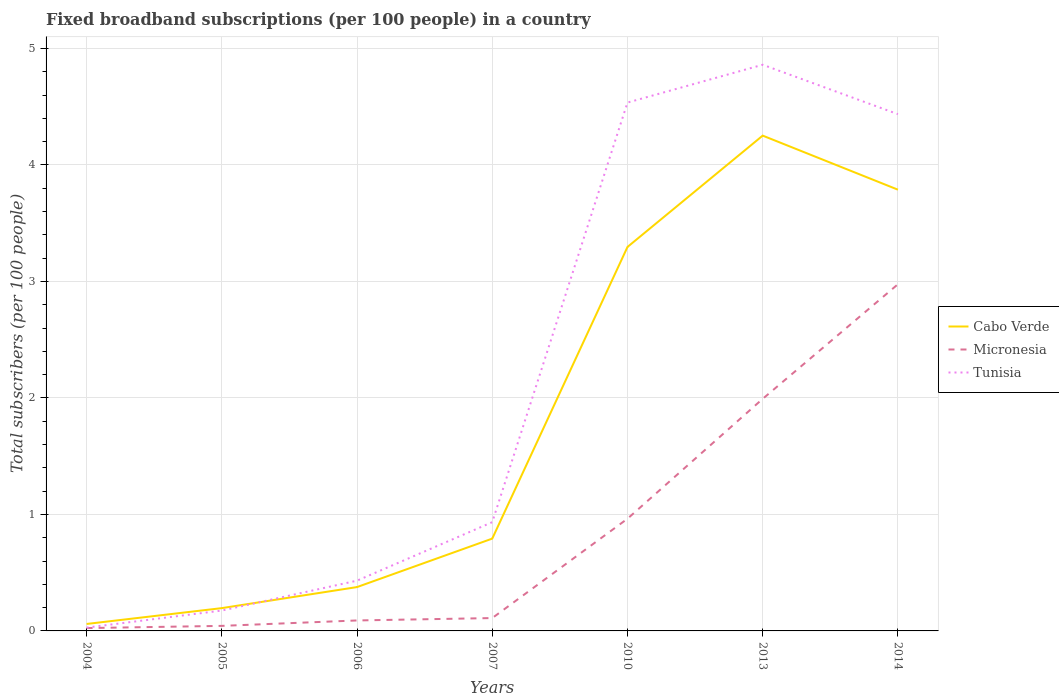How many different coloured lines are there?
Keep it short and to the point. 3. Across all years, what is the maximum number of broadband subscriptions in Tunisia?
Your response must be concise. 0.03. What is the total number of broadband subscriptions in Tunisia in the graph?
Provide a succinct answer. -4.69. What is the difference between the highest and the second highest number of broadband subscriptions in Tunisia?
Your answer should be very brief. 4.83. What is the difference between the highest and the lowest number of broadband subscriptions in Micronesia?
Your answer should be very brief. 3. Is the number of broadband subscriptions in Tunisia strictly greater than the number of broadband subscriptions in Micronesia over the years?
Keep it short and to the point. No. What is the difference between two consecutive major ticks on the Y-axis?
Offer a terse response. 1. How many legend labels are there?
Offer a very short reply. 3. How are the legend labels stacked?
Your answer should be compact. Vertical. What is the title of the graph?
Offer a very short reply. Fixed broadband subscriptions (per 100 people) in a country. Does "Palau" appear as one of the legend labels in the graph?
Make the answer very short. No. What is the label or title of the Y-axis?
Offer a very short reply. Total subscribers (per 100 people). What is the Total subscribers (per 100 people) of Cabo Verde in 2004?
Make the answer very short. 0.06. What is the Total subscribers (per 100 people) in Micronesia in 2004?
Provide a succinct answer. 0.02. What is the Total subscribers (per 100 people) in Tunisia in 2004?
Provide a succinct answer. 0.03. What is the Total subscribers (per 100 people) in Cabo Verde in 2005?
Offer a very short reply. 0.2. What is the Total subscribers (per 100 people) in Micronesia in 2005?
Your answer should be very brief. 0.04. What is the Total subscribers (per 100 people) of Tunisia in 2005?
Offer a very short reply. 0.17. What is the Total subscribers (per 100 people) in Cabo Verde in 2006?
Make the answer very short. 0.38. What is the Total subscribers (per 100 people) of Micronesia in 2006?
Your answer should be very brief. 0.09. What is the Total subscribers (per 100 people) in Tunisia in 2006?
Your answer should be compact. 0.43. What is the Total subscribers (per 100 people) of Cabo Verde in 2007?
Offer a very short reply. 0.79. What is the Total subscribers (per 100 people) in Micronesia in 2007?
Provide a succinct answer. 0.11. What is the Total subscribers (per 100 people) of Tunisia in 2007?
Ensure brevity in your answer.  0.93. What is the Total subscribers (per 100 people) of Cabo Verde in 2010?
Your answer should be compact. 3.3. What is the Total subscribers (per 100 people) of Micronesia in 2010?
Provide a short and direct response. 0.96. What is the Total subscribers (per 100 people) of Tunisia in 2010?
Your answer should be compact. 4.54. What is the Total subscribers (per 100 people) of Cabo Verde in 2013?
Offer a very short reply. 4.25. What is the Total subscribers (per 100 people) in Micronesia in 2013?
Offer a very short reply. 1.99. What is the Total subscribers (per 100 people) in Tunisia in 2013?
Your response must be concise. 4.86. What is the Total subscribers (per 100 people) of Cabo Verde in 2014?
Provide a short and direct response. 3.79. What is the Total subscribers (per 100 people) of Micronesia in 2014?
Offer a terse response. 2.98. What is the Total subscribers (per 100 people) of Tunisia in 2014?
Give a very brief answer. 4.44. Across all years, what is the maximum Total subscribers (per 100 people) in Cabo Verde?
Provide a short and direct response. 4.25. Across all years, what is the maximum Total subscribers (per 100 people) in Micronesia?
Provide a succinct answer. 2.98. Across all years, what is the maximum Total subscribers (per 100 people) in Tunisia?
Offer a very short reply. 4.86. Across all years, what is the minimum Total subscribers (per 100 people) of Cabo Verde?
Make the answer very short. 0.06. Across all years, what is the minimum Total subscribers (per 100 people) of Micronesia?
Your response must be concise. 0.02. Across all years, what is the minimum Total subscribers (per 100 people) of Tunisia?
Offer a terse response. 0.03. What is the total Total subscribers (per 100 people) of Cabo Verde in the graph?
Give a very brief answer. 12.76. What is the total Total subscribers (per 100 people) of Micronesia in the graph?
Your response must be concise. 6.2. What is the total Total subscribers (per 100 people) in Tunisia in the graph?
Your answer should be compact. 15.4. What is the difference between the Total subscribers (per 100 people) in Cabo Verde in 2004 and that in 2005?
Your response must be concise. -0.14. What is the difference between the Total subscribers (per 100 people) in Micronesia in 2004 and that in 2005?
Keep it short and to the point. -0.02. What is the difference between the Total subscribers (per 100 people) in Tunisia in 2004 and that in 2005?
Your response must be concise. -0.15. What is the difference between the Total subscribers (per 100 people) in Cabo Verde in 2004 and that in 2006?
Your response must be concise. -0.32. What is the difference between the Total subscribers (per 100 people) in Micronesia in 2004 and that in 2006?
Offer a terse response. -0.07. What is the difference between the Total subscribers (per 100 people) of Tunisia in 2004 and that in 2006?
Your answer should be very brief. -0.4. What is the difference between the Total subscribers (per 100 people) in Cabo Verde in 2004 and that in 2007?
Keep it short and to the point. -0.73. What is the difference between the Total subscribers (per 100 people) in Micronesia in 2004 and that in 2007?
Your answer should be very brief. -0.09. What is the difference between the Total subscribers (per 100 people) in Tunisia in 2004 and that in 2007?
Give a very brief answer. -0.91. What is the difference between the Total subscribers (per 100 people) of Cabo Verde in 2004 and that in 2010?
Your response must be concise. -3.24. What is the difference between the Total subscribers (per 100 people) in Micronesia in 2004 and that in 2010?
Your answer should be very brief. -0.94. What is the difference between the Total subscribers (per 100 people) in Tunisia in 2004 and that in 2010?
Ensure brevity in your answer.  -4.51. What is the difference between the Total subscribers (per 100 people) in Cabo Verde in 2004 and that in 2013?
Offer a terse response. -4.19. What is the difference between the Total subscribers (per 100 people) in Micronesia in 2004 and that in 2013?
Offer a very short reply. -1.97. What is the difference between the Total subscribers (per 100 people) in Tunisia in 2004 and that in 2013?
Give a very brief answer. -4.83. What is the difference between the Total subscribers (per 100 people) in Cabo Verde in 2004 and that in 2014?
Give a very brief answer. -3.73. What is the difference between the Total subscribers (per 100 people) of Micronesia in 2004 and that in 2014?
Provide a succinct answer. -2.95. What is the difference between the Total subscribers (per 100 people) of Tunisia in 2004 and that in 2014?
Offer a terse response. -4.41. What is the difference between the Total subscribers (per 100 people) of Cabo Verde in 2005 and that in 2006?
Keep it short and to the point. -0.18. What is the difference between the Total subscribers (per 100 people) in Micronesia in 2005 and that in 2006?
Offer a very short reply. -0.05. What is the difference between the Total subscribers (per 100 people) of Tunisia in 2005 and that in 2006?
Keep it short and to the point. -0.26. What is the difference between the Total subscribers (per 100 people) of Cabo Verde in 2005 and that in 2007?
Provide a short and direct response. -0.6. What is the difference between the Total subscribers (per 100 people) of Micronesia in 2005 and that in 2007?
Give a very brief answer. -0.07. What is the difference between the Total subscribers (per 100 people) in Tunisia in 2005 and that in 2007?
Your answer should be compact. -0.76. What is the difference between the Total subscribers (per 100 people) in Cabo Verde in 2005 and that in 2010?
Make the answer very short. -3.1. What is the difference between the Total subscribers (per 100 people) of Micronesia in 2005 and that in 2010?
Ensure brevity in your answer.  -0.92. What is the difference between the Total subscribers (per 100 people) in Tunisia in 2005 and that in 2010?
Keep it short and to the point. -4.36. What is the difference between the Total subscribers (per 100 people) of Cabo Verde in 2005 and that in 2013?
Offer a terse response. -4.06. What is the difference between the Total subscribers (per 100 people) in Micronesia in 2005 and that in 2013?
Your response must be concise. -1.95. What is the difference between the Total subscribers (per 100 people) in Tunisia in 2005 and that in 2013?
Provide a short and direct response. -4.69. What is the difference between the Total subscribers (per 100 people) in Cabo Verde in 2005 and that in 2014?
Your answer should be compact. -3.59. What is the difference between the Total subscribers (per 100 people) of Micronesia in 2005 and that in 2014?
Your answer should be very brief. -2.93. What is the difference between the Total subscribers (per 100 people) of Tunisia in 2005 and that in 2014?
Keep it short and to the point. -4.26. What is the difference between the Total subscribers (per 100 people) in Cabo Verde in 2006 and that in 2007?
Your answer should be very brief. -0.42. What is the difference between the Total subscribers (per 100 people) of Micronesia in 2006 and that in 2007?
Your answer should be compact. -0.02. What is the difference between the Total subscribers (per 100 people) in Tunisia in 2006 and that in 2007?
Provide a succinct answer. -0.5. What is the difference between the Total subscribers (per 100 people) of Cabo Verde in 2006 and that in 2010?
Offer a terse response. -2.92. What is the difference between the Total subscribers (per 100 people) in Micronesia in 2006 and that in 2010?
Provide a succinct answer. -0.87. What is the difference between the Total subscribers (per 100 people) in Tunisia in 2006 and that in 2010?
Make the answer very short. -4.1. What is the difference between the Total subscribers (per 100 people) in Cabo Verde in 2006 and that in 2013?
Keep it short and to the point. -3.88. What is the difference between the Total subscribers (per 100 people) in Micronesia in 2006 and that in 2013?
Provide a short and direct response. -1.9. What is the difference between the Total subscribers (per 100 people) in Tunisia in 2006 and that in 2013?
Offer a terse response. -4.43. What is the difference between the Total subscribers (per 100 people) in Cabo Verde in 2006 and that in 2014?
Ensure brevity in your answer.  -3.41. What is the difference between the Total subscribers (per 100 people) in Micronesia in 2006 and that in 2014?
Offer a very short reply. -2.89. What is the difference between the Total subscribers (per 100 people) of Tunisia in 2006 and that in 2014?
Offer a very short reply. -4. What is the difference between the Total subscribers (per 100 people) of Cabo Verde in 2007 and that in 2010?
Keep it short and to the point. -2.5. What is the difference between the Total subscribers (per 100 people) of Micronesia in 2007 and that in 2010?
Offer a terse response. -0.85. What is the difference between the Total subscribers (per 100 people) of Tunisia in 2007 and that in 2010?
Give a very brief answer. -3.6. What is the difference between the Total subscribers (per 100 people) of Cabo Verde in 2007 and that in 2013?
Your answer should be very brief. -3.46. What is the difference between the Total subscribers (per 100 people) of Micronesia in 2007 and that in 2013?
Provide a succinct answer. -1.88. What is the difference between the Total subscribers (per 100 people) in Tunisia in 2007 and that in 2013?
Keep it short and to the point. -3.93. What is the difference between the Total subscribers (per 100 people) in Cabo Verde in 2007 and that in 2014?
Keep it short and to the point. -3. What is the difference between the Total subscribers (per 100 people) in Micronesia in 2007 and that in 2014?
Make the answer very short. -2.87. What is the difference between the Total subscribers (per 100 people) in Tunisia in 2007 and that in 2014?
Provide a short and direct response. -3.5. What is the difference between the Total subscribers (per 100 people) of Cabo Verde in 2010 and that in 2013?
Your response must be concise. -0.96. What is the difference between the Total subscribers (per 100 people) of Micronesia in 2010 and that in 2013?
Offer a very short reply. -1.03. What is the difference between the Total subscribers (per 100 people) in Tunisia in 2010 and that in 2013?
Make the answer very short. -0.32. What is the difference between the Total subscribers (per 100 people) of Cabo Verde in 2010 and that in 2014?
Ensure brevity in your answer.  -0.49. What is the difference between the Total subscribers (per 100 people) in Micronesia in 2010 and that in 2014?
Your response must be concise. -2.01. What is the difference between the Total subscribers (per 100 people) in Tunisia in 2010 and that in 2014?
Provide a succinct answer. 0.1. What is the difference between the Total subscribers (per 100 people) in Cabo Verde in 2013 and that in 2014?
Offer a very short reply. 0.46. What is the difference between the Total subscribers (per 100 people) in Micronesia in 2013 and that in 2014?
Offer a terse response. -0.98. What is the difference between the Total subscribers (per 100 people) in Tunisia in 2013 and that in 2014?
Provide a succinct answer. 0.42. What is the difference between the Total subscribers (per 100 people) in Cabo Verde in 2004 and the Total subscribers (per 100 people) in Micronesia in 2005?
Your answer should be compact. 0.02. What is the difference between the Total subscribers (per 100 people) of Cabo Verde in 2004 and the Total subscribers (per 100 people) of Tunisia in 2005?
Give a very brief answer. -0.12. What is the difference between the Total subscribers (per 100 people) of Micronesia in 2004 and the Total subscribers (per 100 people) of Tunisia in 2005?
Your response must be concise. -0.15. What is the difference between the Total subscribers (per 100 people) in Cabo Verde in 2004 and the Total subscribers (per 100 people) in Micronesia in 2006?
Ensure brevity in your answer.  -0.03. What is the difference between the Total subscribers (per 100 people) in Cabo Verde in 2004 and the Total subscribers (per 100 people) in Tunisia in 2006?
Your response must be concise. -0.37. What is the difference between the Total subscribers (per 100 people) of Micronesia in 2004 and the Total subscribers (per 100 people) of Tunisia in 2006?
Your answer should be very brief. -0.41. What is the difference between the Total subscribers (per 100 people) of Cabo Verde in 2004 and the Total subscribers (per 100 people) of Micronesia in 2007?
Keep it short and to the point. -0.05. What is the difference between the Total subscribers (per 100 people) of Cabo Verde in 2004 and the Total subscribers (per 100 people) of Tunisia in 2007?
Keep it short and to the point. -0.87. What is the difference between the Total subscribers (per 100 people) of Micronesia in 2004 and the Total subscribers (per 100 people) of Tunisia in 2007?
Your response must be concise. -0.91. What is the difference between the Total subscribers (per 100 people) of Cabo Verde in 2004 and the Total subscribers (per 100 people) of Micronesia in 2010?
Ensure brevity in your answer.  -0.9. What is the difference between the Total subscribers (per 100 people) of Cabo Verde in 2004 and the Total subscribers (per 100 people) of Tunisia in 2010?
Provide a short and direct response. -4.48. What is the difference between the Total subscribers (per 100 people) of Micronesia in 2004 and the Total subscribers (per 100 people) of Tunisia in 2010?
Keep it short and to the point. -4.51. What is the difference between the Total subscribers (per 100 people) of Cabo Verde in 2004 and the Total subscribers (per 100 people) of Micronesia in 2013?
Provide a short and direct response. -1.93. What is the difference between the Total subscribers (per 100 people) in Cabo Verde in 2004 and the Total subscribers (per 100 people) in Tunisia in 2013?
Offer a very short reply. -4.8. What is the difference between the Total subscribers (per 100 people) in Micronesia in 2004 and the Total subscribers (per 100 people) in Tunisia in 2013?
Your answer should be very brief. -4.84. What is the difference between the Total subscribers (per 100 people) in Cabo Verde in 2004 and the Total subscribers (per 100 people) in Micronesia in 2014?
Offer a terse response. -2.92. What is the difference between the Total subscribers (per 100 people) in Cabo Verde in 2004 and the Total subscribers (per 100 people) in Tunisia in 2014?
Your response must be concise. -4.38. What is the difference between the Total subscribers (per 100 people) in Micronesia in 2004 and the Total subscribers (per 100 people) in Tunisia in 2014?
Your response must be concise. -4.41. What is the difference between the Total subscribers (per 100 people) of Cabo Verde in 2005 and the Total subscribers (per 100 people) of Micronesia in 2006?
Provide a short and direct response. 0.11. What is the difference between the Total subscribers (per 100 people) of Cabo Verde in 2005 and the Total subscribers (per 100 people) of Tunisia in 2006?
Provide a succinct answer. -0.24. What is the difference between the Total subscribers (per 100 people) in Micronesia in 2005 and the Total subscribers (per 100 people) in Tunisia in 2006?
Keep it short and to the point. -0.39. What is the difference between the Total subscribers (per 100 people) of Cabo Verde in 2005 and the Total subscribers (per 100 people) of Micronesia in 2007?
Ensure brevity in your answer.  0.09. What is the difference between the Total subscribers (per 100 people) in Cabo Verde in 2005 and the Total subscribers (per 100 people) in Tunisia in 2007?
Keep it short and to the point. -0.74. What is the difference between the Total subscribers (per 100 people) of Micronesia in 2005 and the Total subscribers (per 100 people) of Tunisia in 2007?
Your answer should be compact. -0.89. What is the difference between the Total subscribers (per 100 people) of Cabo Verde in 2005 and the Total subscribers (per 100 people) of Micronesia in 2010?
Keep it short and to the point. -0.77. What is the difference between the Total subscribers (per 100 people) in Cabo Verde in 2005 and the Total subscribers (per 100 people) in Tunisia in 2010?
Provide a short and direct response. -4.34. What is the difference between the Total subscribers (per 100 people) of Micronesia in 2005 and the Total subscribers (per 100 people) of Tunisia in 2010?
Provide a succinct answer. -4.49. What is the difference between the Total subscribers (per 100 people) in Cabo Verde in 2005 and the Total subscribers (per 100 people) in Micronesia in 2013?
Your answer should be compact. -1.8. What is the difference between the Total subscribers (per 100 people) of Cabo Verde in 2005 and the Total subscribers (per 100 people) of Tunisia in 2013?
Offer a very short reply. -4.66. What is the difference between the Total subscribers (per 100 people) of Micronesia in 2005 and the Total subscribers (per 100 people) of Tunisia in 2013?
Your answer should be compact. -4.82. What is the difference between the Total subscribers (per 100 people) of Cabo Verde in 2005 and the Total subscribers (per 100 people) of Micronesia in 2014?
Your response must be concise. -2.78. What is the difference between the Total subscribers (per 100 people) of Cabo Verde in 2005 and the Total subscribers (per 100 people) of Tunisia in 2014?
Give a very brief answer. -4.24. What is the difference between the Total subscribers (per 100 people) of Micronesia in 2005 and the Total subscribers (per 100 people) of Tunisia in 2014?
Give a very brief answer. -4.39. What is the difference between the Total subscribers (per 100 people) in Cabo Verde in 2006 and the Total subscribers (per 100 people) in Micronesia in 2007?
Your answer should be very brief. 0.27. What is the difference between the Total subscribers (per 100 people) in Cabo Verde in 2006 and the Total subscribers (per 100 people) in Tunisia in 2007?
Your answer should be very brief. -0.56. What is the difference between the Total subscribers (per 100 people) in Micronesia in 2006 and the Total subscribers (per 100 people) in Tunisia in 2007?
Give a very brief answer. -0.84. What is the difference between the Total subscribers (per 100 people) in Cabo Verde in 2006 and the Total subscribers (per 100 people) in Micronesia in 2010?
Offer a very short reply. -0.59. What is the difference between the Total subscribers (per 100 people) in Cabo Verde in 2006 and the Total subscribers (per 100 people) in Tunisia in 2010?
Keep it short and to the point. -4.16. What is the difference between the Total subscribers (per 100 people) of Micronesia in 2006 and the Total subscribers (per 100 people) of Tunisia in 2010?
Your answer should be compact. -4.45. What is the difference between the Total subscribers (per 100 people) in Cabo Verde in 2006 and the Total subscribers (per 100 people) in Micronesia in 2013?
Your answer should be compact. -1.62. What is the difference between the Total subscribers (per 100 people) of Cabo Verde in 2006 and the Total subscribers (per 100 people) of Tunisia in 2013?
Ensure brevity in your answer.  -4.48. What is the difference between the Total subscribers (per 100 people) in Micronesia in 2006 and the Total subscribers (per 100 people) in Tunisia in 2013?
Give a very brief answer. -4.77. What is the difference between the Total subscribers (per 100 people) in Cabo Verde in 2006 and the Total subscribers (per 100 people) in Micronesia in 2014?
Provide a succinct answer. -2.6. What is the difference between the Total subscribers (per 100 people) in Cabo Verde in 2006 and the Total subscribers (per 100 people) in Tunisia in 2014?
Offer a very short reply. -4.06. What is the difference between the Total subscribers (per 100 people) in Micronesia in 2006 and the Total subscribers (per 100 people) in Tunisia in 2014?
Keep it short and to the point. -4.35. What is the difference between the Total subscribers (per 100 people) of Cabo Verde in 2007 and the Total subscribers (per 100 people) of Micronesia in 2010?
Give a very brief answer. -0.17. What is the difference between the Total subscribers (per 100 people) of Cabo Verde in 2007 and the Total subscribers (per 100 people) of Tunisia in 2010?
Offer a terse response. -3.74. What is the difference between the Total subscribers (per 100 people) of Micronesia in 2007 and the Total subscribers (per 100 people) of Tunisia in 2010?
Give a very brief answer. -4.43. What is the difference between the Total subscribers (per 100 people) of Cabo Verde in 2007 and the Total subscribers (per 100 people) of Micronesia in 2013?
Make the answer very short. -1.2. What is the difference between the Total subscribers (per 100 people) of Cabo Verde in 2007 and the Total subscribers (per 100 people) of Tunisia in 2013?
Your response must be concise. -4.07. What is the difference between the Total subscribers (per 100 people) in Micronesia in 2007 and the Total subscribers (per 100 people) in Tunisia in 2013?
Offer a terse response. -4.75. What is the difference between the Total subscribers (per 100 people) in Cabo Verde in 2007 and the Total subscribers (per 100 people) in Micronesia in 2014?
Provide a succinct answer. -2.18. What is the difference between the Total subscribers (per 100 people) of Cabo Verde in 2007 and the Total subscribers (per 100 people) of Tunisia in 2014?
Give a very brief answer. -3.64. What is the difference between the Total subscribers (per 100 people) in Micronesia in 2007 and the Total subscribers (per 100 people) in Tunisia in 2014?
Provide a succinct answer. -4.33. What is the difference between the Total subscribers (per 100 people) in Cabo Verde in 2010 and the Total subscribers (per 100 people) in Micronesia in 2013?
Your answer should be very brief. 1.3. What is the difference between the Total subscribers (per 100 people) in Cabo Verde in 2010 and the Total subscribers (per 100 people) in Tunisia in 2013?
Provide a short and direct response. -1.56. What is the difference between the Total subscribers (per 100 people) of Micronesia in 2010 and the Total subscribers (per 100 people) of Tunisia in 2013?
Ensure brevity in your answer.  -3.9. What is the difference between the Total subscribers (per 100 people) of Cabo Verde in 2010 and the Total subscribers (per 100 people) of Micronesia in 2014?
Make the answer very short. 0.32. What is the difference between the Total subscribers (per 100 people) of Cabo Verde in 2010 and the Total subscribers (per 100 people) of Tunisia in 2014?
Keep it short and to the point. -1.14. What is the difference between the Total subscribers (per 100 people) of Micronesia in 2010 and the Total subscribers (per 100 people) of Tunisia in 2014?
Ensure brevity in your answer.  -3.47. What is the difference between the Total subscribers (per 100 people) of Cabo Verde in 2013 and the Total subscribers (per 100 people) of Micronesia in 2014?
Provide a succinct answer. 1.28. What is the difference between the Total subscribers (per 100 people) of Cabo Verde in 2013 and the Total subscribers (per 100 people) of Tunisia in 2014?
Keep it short and to the point. -0.18. What is the difference between the Total subscribers (per 100 people) in Micronesia in 2013 and the Total subscribers (per 100 people) in Tunisia in 2014?
Your response must be concise. -2.44. What is the average Total subscribers (per 100 people) in Cabo Verde per year?
Provide a short and direct response. 1.82. What is the average Total subscribers (per 100 people) in Micronesia per year?
Give a very brief answer. 0.89. In the year 2004, what is the difference between the Total subscribers (per 100 people) of Cabo Verde and Total subscribers (per 100 people) of Micronesia?
Offer a terse response. 0.04. In the year 2004, what is the difference between the Total subscribers (per 100 people) in Cabo Verde and Total subscribers (per 100 people) in Tunisia?
Ensure brevity in your answer.  0.03. In the year 2004, what is the difference between the Total subscribers (per 100 people) of Micronesia and Total subscribers (per 100 people) of Tunisia?
Give a very brief answer. -0. In the year 2005, what is the difference between the Total subscribers (per 100 people) in Cabo Verde and Total subscribers (per 100 people) in Micronesia?
Your response must be concise. 0.15. In the year 2005, what is the difference between the Total subscribers (per 100 people) in Cabo Verde and Total subscribers (per 100 people) in Tunisia?
Provide a succinct answer. 0.02. In the year 2005, what is the difference between the Total subscribers (per 100 people) of Micronesia and Total subscribers (per 100 people) of Tunisia?
Give a very brief answer. -0.13. In the year 2006, what is the difference between the Total subscribers (per 100 people) in Cabo Verde and Total subscribers (per 100 people) in Micronesia?
Your answer should be compact. 0.29. In the year 2006, what is the difference between the Total subscribers (per 100 people) of Cabo Verde and Total subscribers (per 100 people) of Tunisia?
Keep it short and to the point. -0.06. In the year 2006, what is the difference between the Total subscribers (per 100 people) of Micronesia and Total subscribers (per 100 people) of Tunisia?
Make the answer very short. -0.34. In the year 2007, what is the difference between the Total subscribers (per 100 people) in Cabo Verde and Total subscribers (per 100 people) in Micronesia?
Offer a terse response. 0.68. In the year 2007, what is the difference between the Total subscribers (per 100 people) in Cabo Verde and Total subscribers (per 100 people) in Tunisia?
Offer a very short reply. -0.14. In the year 2007, what is the difference between the Total subscribers (per 100 people) in Micronesia and Total subscribers (per 100 people) in Tunisia?
Your answer should be very brief. -0.82. In the year 2010, what is the difference between the Total subscribers (per 100 people) in Cabo Verde and Total subscribers (per 100 people) in Micronesia?
Your answer should be very brief. 2.33. In the year 2010, what is the difference between the Total subscribers (per 100 people) in Cabo Verde and Total subscribers (per 100 people) in Tunisia?
Give a very brief answer. -1.24. In the year 2010, what is the difference between the Total subscribers (per 100 people) of Micronesia and Total subscribers (per 100 people) of Tunisia?
Provide a succinct answer. -3.57. In the year 2013, what is the difference between the Total subscribers (per 100 people) in Cabo Verde and Total subscribers (per 100 people) in Micronesia?
Provide a short and direct response. 2.26. In the year 2013, what is the difference between the Total subscribers (per 100 people) in Cabo Verde and Total subscribers (per 100 people) in Tunisia?
Make the answer very short. -0.61. In the year 2013, what is the difference between the Total subscribers (per 100 people) of Micronesia and Total subscribers (per 100 people) of Tunisia?
Your response must be concise. -2.87. In the year 2014, what is the difference between the Total subscribers (per 100 people) of Cabo Verde and Total subscribers (per 100 people) of Micronesia?
Your response must be concise. 0.81. In the year 2014, what is the difference between the Total subscribers (per 100 people) of Cabo Verde and Total subscribers (per 100 people) of Tunisia?
Your response must be concise. -0.65. In the year 2014, what is the difference between the Total subscribers (per 100 people) of Micronesia and Total subscribers (per 100 people) of Tunisia?
Ensure brevity in your answer.  -1.46. What is the ratio of the Total subscribers (per 100 people) in Cabo Verde in 2004 to that in 2005?
Keep it short and to the point. 0.31. What is the ratio of the Total subscribers (per 100 people) of Micronesia in 2004 to that in 2005?
Make the answer very short. 0.56. What is the ratio of the Total subscribers (per 100 people) in Tunisia in 2004 to that in 2005?
Provide a succinct answer. 0.16. What is the ratio of the Total subscribers (per 100 people) of Cabo Verde in 2004 to that in 2006?
Give a very brief answer. 0.16. What is the ratio of the Total subscribers (per 100 people) in Micronesia in 2004 to that in 2006?
Keep it short and to the point. 0.27. What is the ratio of the Total subscribers (per 100 people) of Tunisia in 2004 to that in 2006?
Provide a succinct answer. 0.07. What is the ratio of the Total subscribers (per 100 people) of Cabo Verde in 2004 to that in 2007?
Give a very brief answer. 0.08. What is the ratio of the Total subscribers (per 100 people) in Micronesia in 2004 to that in 2007?
Your response must be concise. 0.22. What is the ratio of the Total subscribers (per 100 people) of Tunisia in 2004 to that in 2007?
Ensure brevity in your answer.  0.03. What is the ratio of the Total subscribers (per 100 people) of Cabo Verde in 2004 to that in 2010?
Provide a succinct answer. 0.02. What is the ratio of the Total subscribers (per 100 people) of Micronesia in 2004 to that in 2010?
Make the answer very short. 0.03. What is the ratio of the Total subscribers (per 100 people) in Tunisia in 2004 to that in 2010?
Your answer should be compact. 0.01. What is the ratio of the Total subscribers (per 100 people) in Cabo Verde in 2004 to that in 2013?
Your response must be concise. 0.01. What is the ratio of the Total subscribers (per 100 people) of Micronesia in 2004 to that in 2013?
Offer a very short reply. 0.01. What is the ratio of the Total subscribers (per 100 people) in Tunisia in 2004 to that in 2013?
Ensure brevity in your answer.  0.01. What is the ratio of the Total subscribers (per 100 people) in Cabo Verde in 2004 to that in 2014?
Offer a very short reply. 0.02. What is the ratio of the Total subscribers (per 100 people) of Micronesia in 2004 to that in 2014?
Your answer should be very brief. 0.01. What is the ratio of the Total subscribers (per 100 people) of Tunisia in 2004 to that in 2014?
Keep it short and to the point. 0.01. What is the ratio of the Total subscribers (per 100 people) in Cabo Verde in 2005 to that in 2006?
Make the answer very short. 0.52. What is the ratio of the Total subscribers (per 100 people) in Micronesia in 2005 to that in 2006?
Your answer should be very brief. 0.48. What is the ratio of the Total subscribers (per 100 people) in Tunisia in 2005 to that in 2006?
Your answer should be compact. 0.41. What is the ratio of the Total subscribers (per 100 people) in Cabo Verde in 2005 to that in 2007?
Ensure brevity in your answer.  0.25. What is the ratio of the Total subscribers (per 100 people) in Micronesia in 2005 to that in 2007?
Ensure brevity in your answer.  0.39. What is the ratio of the Total subscribers (per 100 people) of Tunisia in 2005 to that in 2007?
Ensure brevity in your answer.  0.19. What is the ratio of the Total subscribers (per 100 people) of Cabo Verde in 2005 to that in 2010?
Provide a succinct answer. 0.06. What is the ratio of the Total subscribers (per 100 people) of Micronesia in 2005 to that in 2010?
Provide a short and direct response. 0.04. What is the ratio of the Total subscribers (per 100 people) in Tunisia in 2005 to that in 2010?
Your answer should be compact. 0.04. What is the ratio of the Total subscribers (per 100 people) of Cabo Verde in 2005 to that in 2013?
Keep it short and to the point. 0.05. What is the ratio of the Total subscribers (per 100 people) of Micronesia in 2005 to that in 2013?
Offer a terse response. 0.02. What is the ratio of the Total subscribers (per 100 people) of Tunisia in 2005 to that in 2013?
Your answer should be very brief. 0.04. What is the ratio of the Total subscribers (per 100 people) in Cabo Verde in 2005 to that in 2014?
Make the answer very short. 0.05. What is the ratio of the Total subscribers (per 100 people) of Micronesia in 2005 to that in 2014?
Keep it short and to the point. 0.01. What is the ratio of the Total subscribers (per 100 people) in Tunisia in 2005 to that in 2014?
Provide a short and direct response. 0.04. What is the ratio of the Total subscribers (per 100 people) of Cabo Verde in 2006 to that in 2007?
Ensure brevity in your answer.  0.47. What is the ratio of the Total subscribers (per 100 people) in Micronesia in 2006 to that in 2007?
Your response must be concise. 0.81. What is the ratio of the Total subscribers (per 100 people) of Tunisia in 2006 to that in 2007?
Provide a short and direct response. 0.46. What is the ratio of the Total subscribers (per 100 people) in Cabo Verde in 2006 to that in 2010?
Make the answer very short. 0.11. What is the ratio of the Total subscribers (per 100 people) of Micronesia in 2006 to that in 2010?
Keep it short and to the point. 0.09. What is the ratio of the Total subscribers (per 100 people) of Tunisia in 2006 to that in 2010?
Provide a succinct answer. 0.1. What is the ratio of the Total subscribers (per 100 people) in Cabo Verde in 2006 to that in 2013?
Your answer should be compact. 0.09. What is the ratio of the Total subscribers (per 100 people) of Micronesia in 2006 to that in 2013?
Provide a succinct answer. 0.05. What is the ratio of the Total subscribers (per 100 people) of Tunisia in 2006 to that in 2013?
Provide a short and direct response. 0.09. What is the ratio of the Total subscribers (per 100 people) in Cabo Verde in 2006 to that in 2014?
Make the answer very short. 0.1. What is the ratio of the Total subscribers (per 100 people) in Micronesia in 2006 to that in 2014?
Provide a short and direct response. 0.03. What is the ratio of the Total subscribers (per 100 people) of Tunisia in 2006 to that in 2014?
Give a very brief answer. 0.1. What is the ratio of the Total subscribers (per 100 people) in Cabo Verde in 2007 to that in 2010?
Your answer should be very brief. 0.24. What is the ratio of the Total subscribers (per 100 people) of Micronesia in 2007 to that in 2010?
Your response must be concise. 0.11. What is the ratio of the Total subscribers (per 100 people) in Tunisia in 2007 to that in 2010?
Ensure brevity in your answer.  0.21. What is the ratio of the Total subscribers (per 100 people) of Cabo Verde in 2007 to that in 2013?
Offer a terse response. 0.19. What is the ratio of the Total subscribers (per 100 people) of Micronesia in 2007 to that in 2013?
Give a very brief answer. 0.06. What is the ratio of the Total subscribers (per 100 people) of Tunisia in 2007 to that in 2013?
Keep it short and to the point. 0.19. What is the ratio of the Total subscribers (per 100 people) of Cabo Verde in 2007 to that in 2014?
Your response must be concise. 0.21. What is the ratio of the Total subscribers (per 100 people) of Micronesia in 2007 to that in 2014?
Ensure brevity in your answer.  0.04. What is the ratio of the Total subscribers (per 100 people) in Tunisia in 2007 to that in 2014?
Provide a succinct answer. 0.21. What is the ratio of the Total subscribers (per 100 people) of Cabo Verde in 2010 to that in 2013?
Provide a succinct answer. 0.78. What is the ratio of the Total subscribers (per 100 people) in Micronesia in 2010 to that in 2013?
Provide a short and direct response. 0.48. What is the ratio of the Total subscribers (per 100 people) of Tunisia in 2010 to that in 2013?
Offer a very short reply. 0.93. What is the ratio of the Total subscribers (per 100 people) in Cabo Verde in 2010 to that in 2014?
Your answer should be compact. 0.87. What is the ratio of the Total subscribers (per 100 people) of Micronesia in 2010 to that in 2014?
Provide a succinct answer. 0.32. What is the ratio of the Total subscribers (per 100 people) in Tunisia in 2010 to that in 2014?
Offer a very short reply. 1.02. What is the ratio of the Total subscribers (per 100 people) of Cabo Verde in 2013 to that in 2014?
Keep it short and to the point. 1.12. What is the ratio of the Total subscribers (per 100 people) in Micronesia in 2013 to that in 2014?
Offer a terse response. 0.67. What is the ratio of the Total subscribers (per 100 people) of Tunisia in 2013 to that in 2014?
Your answer should be very brief. 1.1. What is the difference between the highest and the second highest Total subscribers (per 100 people) of Cabo Verde?
Keep it short and to the point. 0.46. What is the difference between the highest and the second highest Total subscribers (per 100 people) in Micronesia?
Your answer should be compact. 0.98. What is the difference between the highest and the second highest Total subscribers (per 100 people) in Tunisia?
Your response must be concise. 0.32. What is the difference between the highest and the lowest Total subscribers (per 100 people) of Cabo Verde?
Your response must be concise. 4.19. What is the difference between the highest and the lowest Total subscribers (per 100 people) in Micronesia?
Ensure brevity in your answer.  2.95. What is the difference between the highest and the lowest Total subscribers (per 100 people) of Tunisia?
Offer a terse response. 4.83. 